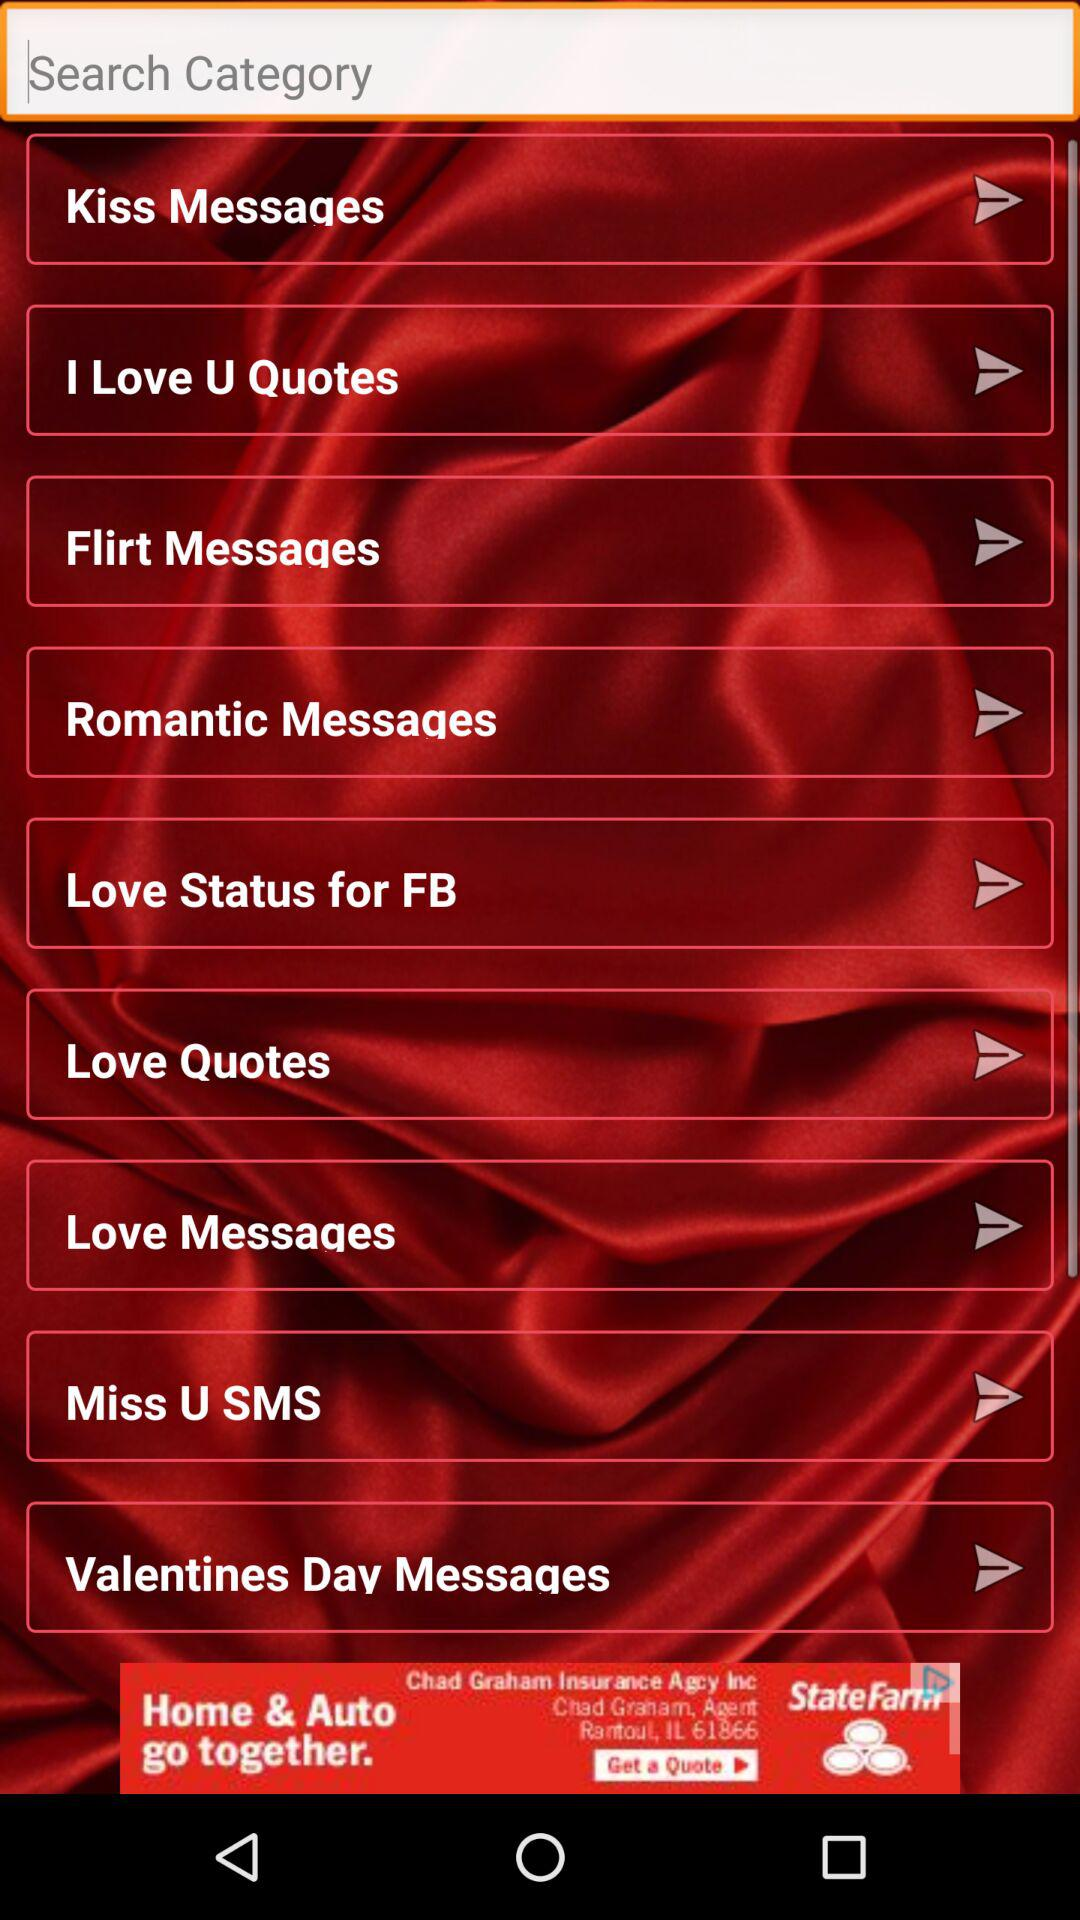What are the different available categories of messages? The different available categories are "Kiss Messages", "Flirt Messages", "Romantic Messages", "Love Messages" and "Valentines Day Messages". 